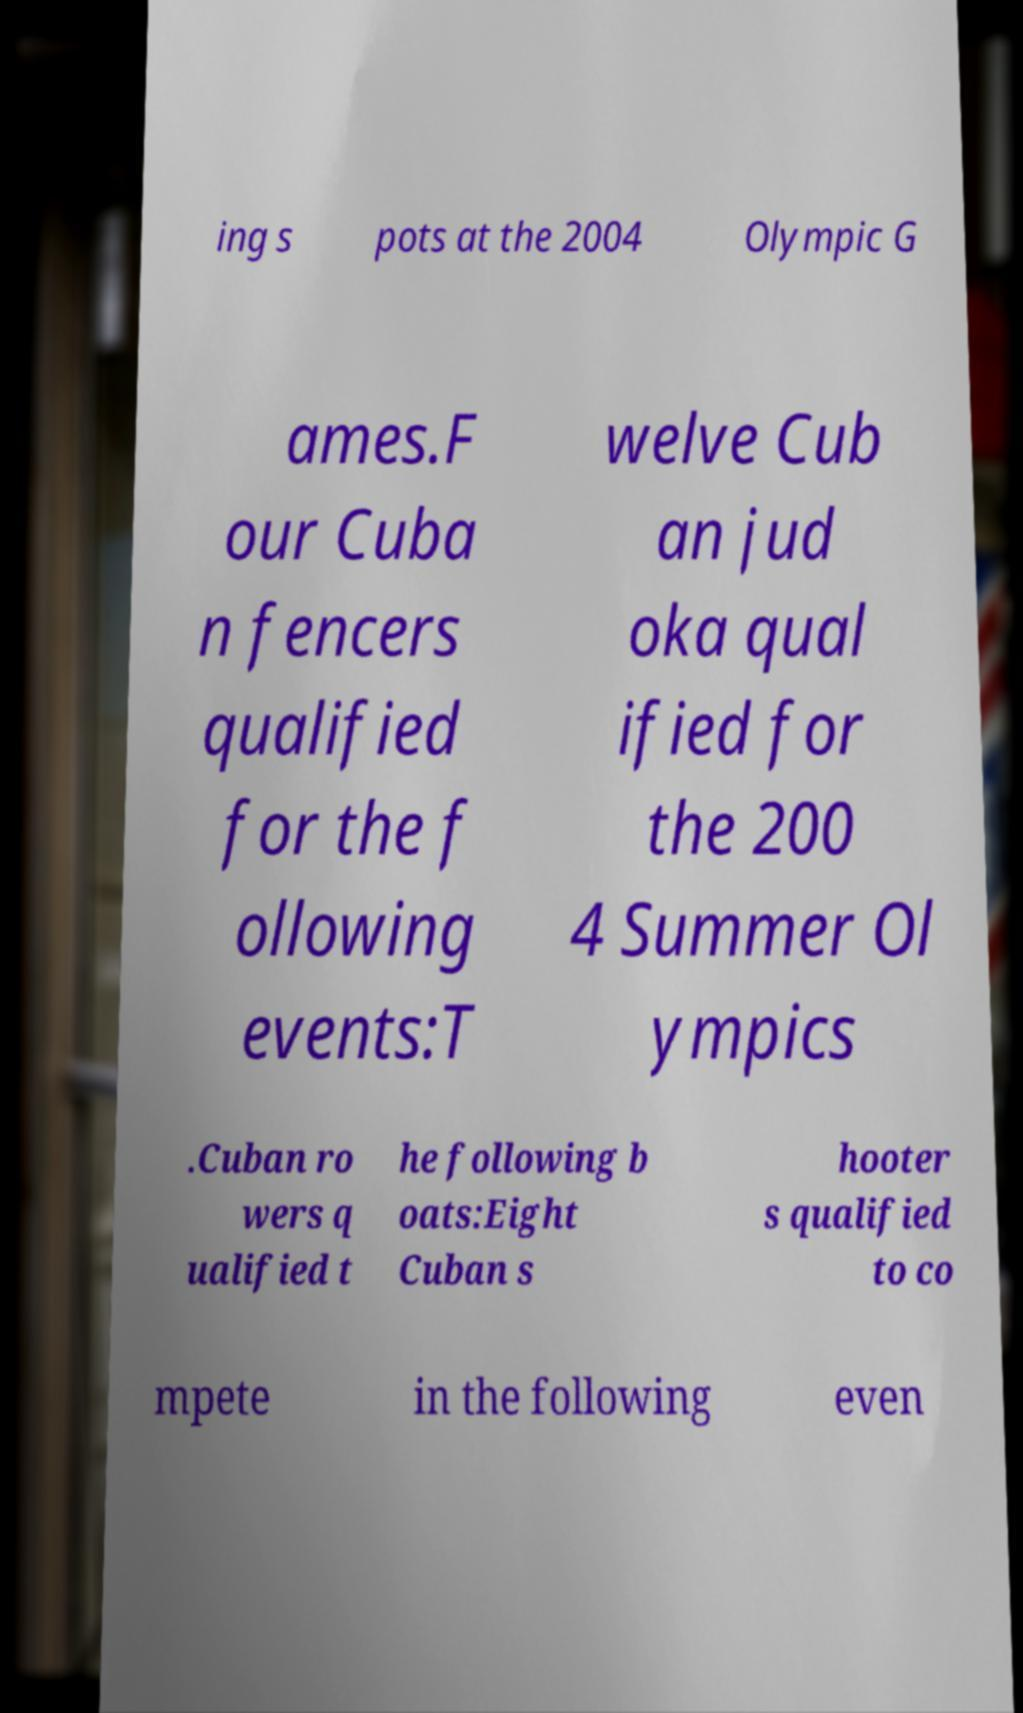There's text embedded in this image that I need extracted. Can you transcribe it verbatim? ing s pots at the 2004 Olympic G ames.F our Cuba n fencers qualified for the f ollowing events:T welve Cub an jud oka qual ified for the 200 4 Summer Ol ympics .Cuban ro wers q ualified t he following b oats:Eight Cuban s hooter s qualified to co mpete in the following even 